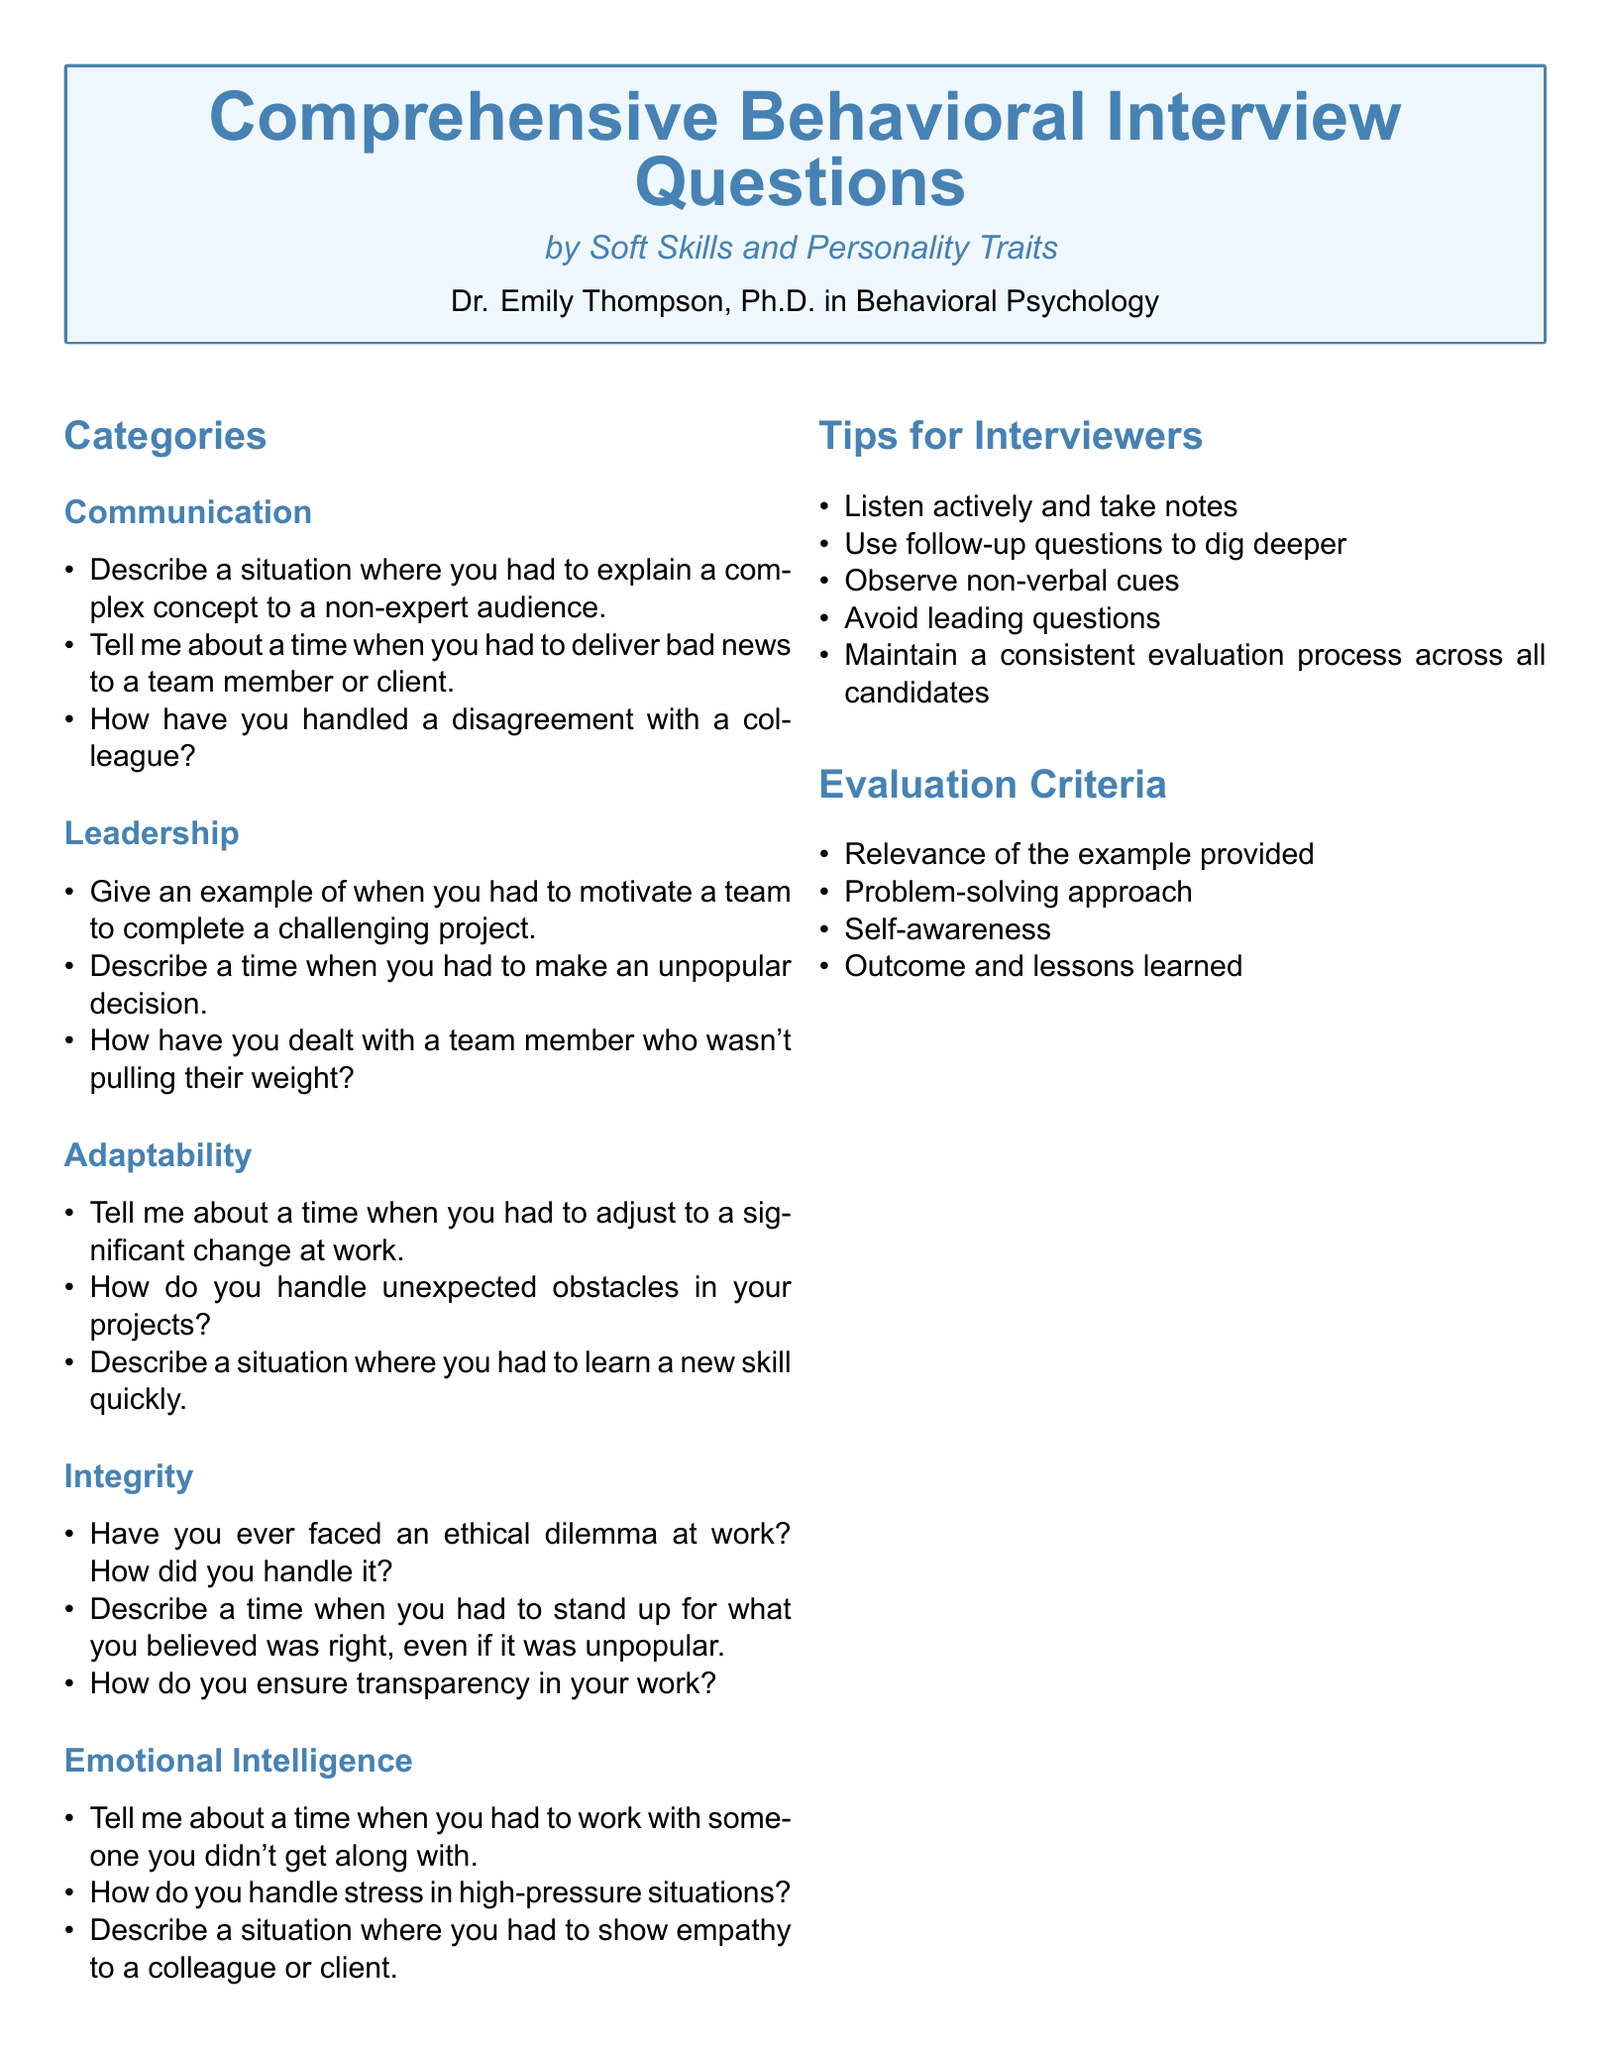What is the title of the document? The title of the document is stated at the top in a prominent format.
Answer: Comprehensive Behavioral Interview Questions Who is the author of the document? The author is mentioned at the end of the title section.
Answer: Dr. Emily Thompson, Ph.D. in Behavioral Psychology How many categories are listed in the document? The document has a specific part that enumerates the categories present.
Answer: 5 What is one question listed under the Communication category? A specific question can be identified from the items under the Communication section.
Answer: Describe a situation where you had to explain a complex concept to a non-expert audience What is the color used for the main section headings? The color for the main section headings is defined in the document's styling section.
Answer: RGB(70,130,180) What is one tip provided for interviewers? The document includes a list of tips for interviewers which can be directly referenced.
Answer: Listen actively and take notes What are the evaluation criteria mentioned? The evaluation criteria are explicitly listed in a section of the document.
Answer: Relevance of the example provided What personality trait is associated with the question about ethical dilemmas? The questions are categorized under specific traits, leading to a certain understanding.
Answer: Integrity What is the main format of the document? The structure and layout specifics indicate the type of document produced.
Answer: Catalog 